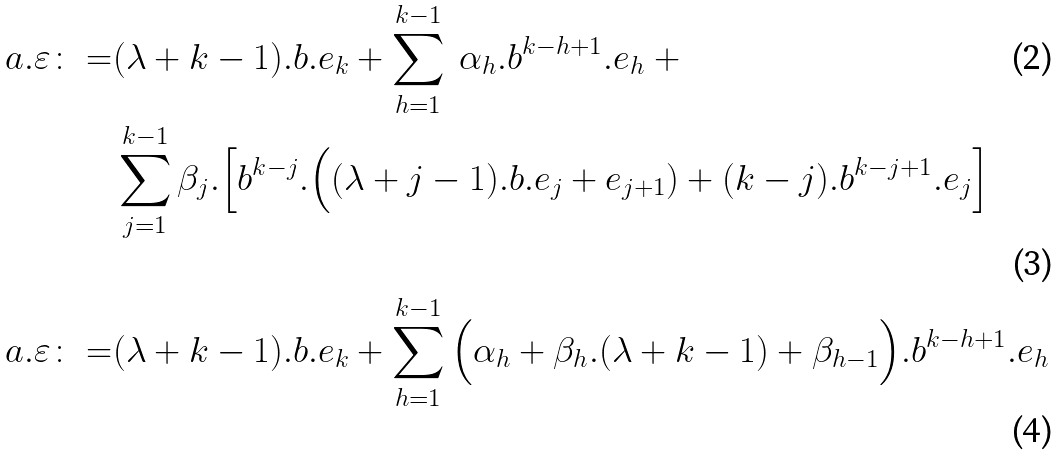<formula> <loc_0><loc_0><loc_500><loc_500>a . \varepsilon \colon = & ( \lambda + k - 1 ) . b . e _ { k } + \sum _ { h = 1 } ^ { k - 1 } \ \alpha _ { h } . b ^ { k - h + 1 } . e _ { h } \ + \\ \quad & \sum _ { j = 1 } ^ { k - 1 } \beta _ { j } . \Big [ b ^ { k - j } . \Big ( ( \lambda + j - 1 ) . b . e _ { j } + e _ { j + 1 } ) + ( k - j ) . b ^ { k - j + 1 } . e _ { j } \Big ] \\ a . \varepsilon \colon = & ( \lambda + k - 1 ) . b . e _ { k } + \sum _ { h = 1 } ^ { k - 1 } \Big ( \alpha _ { h } + \beta _ { h } . ( \lambda + k - 1 ) + \beta _ { h - 1 } \Big ) . b ^ { k - h + 1 } . e _ { h }</formula> 